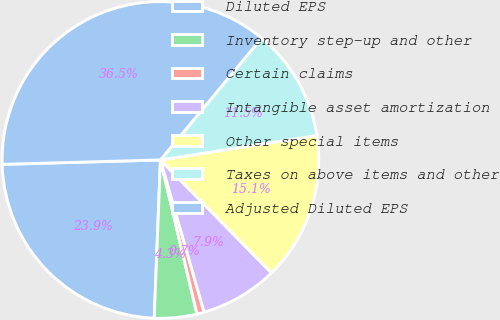Convert chart to OTSL. <chart><loc_0><loc_0><loc_500><loc_500><pie_chart><fcel>Diluted EPS<fcel>Inventory step-up and other<fcel>Certain claims<fcel>Intangible asset amortization<fcel>Other special items<fcel>Taxes on above items and other<fcel>Adjusted Diluted EPS<nl><fcel>23.93%<fcel>4.33%<fcel>0.74%<fcel>7.92%<fcel>15.1%<fcel>11.51%<fcel>36.47%<nl></chart> 